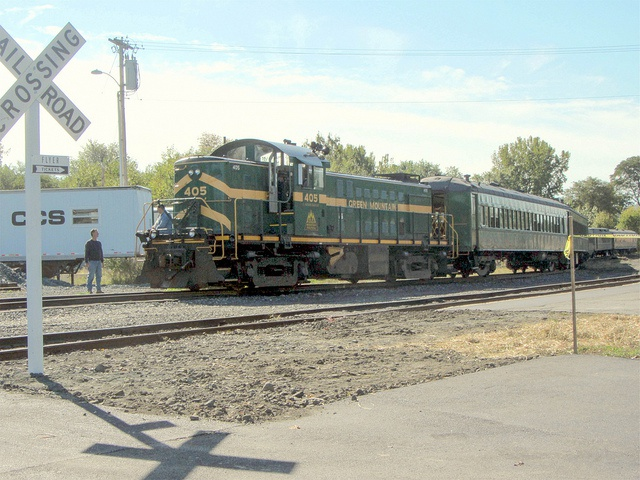Describe the objects in this image and their specific colors. I can see train in lightblue, gray, black, tan, and darkgray tones, truck in lightblue, darkgray, and gray tones, people in lightblue, gray, and black tones, and people in lightblue, gray, darkgray, and beige tones in this image. 